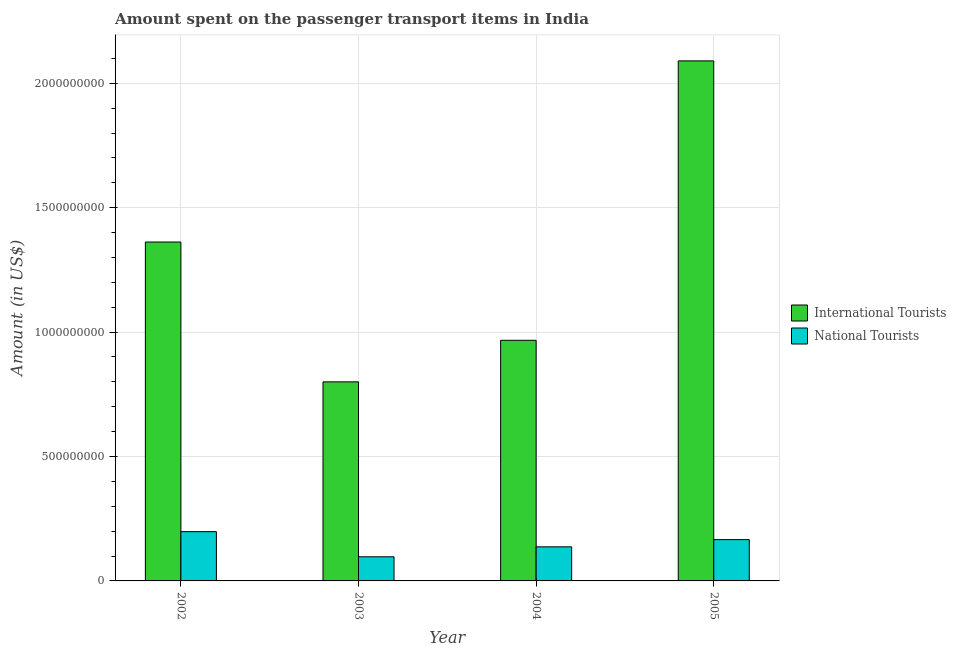How many different coloured bars are there?
Provide a succinct answer. 2. Are the number of bars on each tick of the X-axis equal?
Provide a short and direct response. Yes. How many bars are there on the 2nd tick from the right?
Provide a succinct answer. 2. What is the label of the 1st group of bars from the left?
Provide a succinct answer. 2002. In how many cases, is the number of bars for a given year not equal to the number of legend labels?
Offer a very short reply. 0. What is the amount spent on transport items of national tourists in 2003?
Offer a very short reply. 9.70e+07. Across all years, what is the maximum amount spent on transport items of national tourists?
Offer a very short reply. 1.98e+08. Across all years, what is the minimum amount spent on transport items of international tourists?
Your answer should be compact. 8.00e+08. In which year was the amount spent on transport items of national tourists maximum?
Provide a succinct answer. 2002. In which year was the amount spent on transport items of national tourists minimum?
Give a very brief answer. 2003. What is the total amount spent on transport items of international tourists in the graph?
Give a very brief answer. 5.22e+09. What is the difference between the amount spent on transport items of international tourists in 2003 and that in 2005?
Your answer should be very brief. -1.29e+09. What is the difference between the amount spent on transport items of national tourists in 2005 and the amount spent on transport items of international tourists in 2004?
Offer a very short reply. 2.90e+07. What is the average amount spent on transport items of national tourists per year?
Offer a terse response. 1.50e+08. In how many years, is the amount spent on transport items of national tourists greater than 100000000 US$?
Provide a short and direct response. 3. What is the ratio of the amount spent on transport items of international tourists in 2003 to that in 2004?
Ensure brevity in your answer.  0.83. Is the amount spent on transport items of international tourists in 2004 less than that in 2005?
Provide a succinct answer. Yes. Is the difference between the amount spent on transport items of national tourists in 2003 and 2004 greater than the difference between the amount spent on transport items of international tourists in 2003 and 2004?
Provide a short and direct response. No. What is the difference between the highest and the second highest amount spent on transport items of international tourists?
Offer a very short reply. 7.28e+08. What is the difference between the highest and the lowest amount spent on transport items of international tourists?
Make the answer very short. 1.29e+09. What does the 1st bar from the left in 2004 represents?
Your response must be concise. International Tourists. What does the 1st bar from the right in 2003 represents?
Offer a terse response. National Tourists. Are all the bars in the graph horizontal?
Offer a terse response. No. How many years are there in the graph?
Your answer should be compact. 4. Are the values on the major ticks of Y-axis written in scientific E-notation?
Make the answer very short. No. Does the graph contain grids?
Offer a terse response. Yes. How many legend labels are there?
Give a very brief answer. 2. What is the title of the graph?
Provide a short and direct response. Amount spent on the passenger transport items in India. What is the Amount (in US$) in International Tourists in 2002?
Make the answer very short. 1.36e+09. What is the Amount (in US$) of National Tourists in 2002?
Offer a very short reply. 1.98e+08. What is the Amount (in US$) of International Tourists in 2003?
Keep it short and to the point. 8.00e+08. What is the Amount (in US$) in National Tourists in 2003?
Provide a short and direct response. 9.70e+07. What is the Amount (in US$) of International Tourists in 2004?
Your response must be concise. 9.67e+08. What is the Amount (in US$) in National Tourists in 2004?
Provide a short and direct response. 1.37e+08. What is the Amount (in US$) of International Tourists in 2005?
Provide a short and direct response. 2.09e+09. What is the Amount (in US$) of National Tourists in 2005?
Offer a terse response. 1.66e+08. Across all years, what is the maximum Amount (in US$) in International Tourists?
Your response must be concise. 2.09e+09. Across all years, what is the maximum Amount (in US$) of National Tourists?
Your answer should be compact. 1.98e+08. Across all years, what is the minimum Amount (in US$) of International Tourists?
Your answer should be compact. 8.00e+08. Across all years, what is the minimum Amount (in US$) of National Tourists?
Your response must be concise. 9.70e+07. What is the total Amount (in US$) in International Tourists in the graph?
Give a very brief answer. 5.22e+09. What is the total Amount (in US$) in National Tourists in the graph?
Give a very brief answer. 5.98e+08. What is the difference between the Amount (in US$) of International Tourists in 2002 and that in 2003?
Your response must be concise. 5.62e+08. What is the difference between the Amount (in US$) in National Tourists in 2002 and that in 2003?
Your answer should be compact. 1.01e+08. What is the difference between the Amount (in US$) of International Tourists in 2002 and that in 2004?
Your response must be concise. 3.95e+08. What is the difference between the Amount (in US$) of National Tourists in 2002 and that in 2004?
Offer a very short reply. 6.10e+07. What is the difference between the Amount (in US$) in International Tourists in 2002 and that in 2005?
Provide a short and direct response. -7.28e+08. What is the difference between the Amount (in US$) of National Tourists in 2002 and that in 2005?
Provide a succinct answer. 3.20e+07. What is the difference between the Amount (in US$) of International Tourists in 2003 and that in 2004?
Make the answer very short. -1.67e+08. What is the difference between the Amount (in US$) in National Tourists in 2003 and that in 2004?
Ensure brevity in your answer.  -4.00e+07. What is the difference between the Amount (in US$) of International Tourists in 2003 and that in 2005?
Your answer should be very brief. -1.29e+09. What is the difference between the Amount (in US$) in National Tourists in 2003 and that in 2005?
Provide a short and direct response. -6.90e+07. What is the difference between the Amount (in US$) of International Tourists in 2004 and that in 2005?
Make the answer very short. -1.12e+09. What is the difference between the Amount (in US$) of National Tourists in 2004 and that in 2005?
Ensure brevity in your answer.  -2.90e+07. What is the difference between the Amount (in US$) in International Tourists in 2002 and the Amount (in US$) in National Tourists in 2003?
Offer a terse response. 1.26e+09. What is the difference between the Amount (in US$) in International Tourists in 2002 and the Amount (in US$) in National Tourists in 2004?
Provide a succinct answer. 1.22e+09. What is the difference between the Amount (in US$) of International Tourists in 2002 and the Amount (in US$) of National Tourists in 2005?
Your answer should be compact. 1.20e+09. What is the difference between the Amount (in US$) in International Tourists in 2003 and the Amount (in US$) in National Tourists in 2004?
Offer a terse response. 6.63e+08. What is the difference between the Amount (in US$) of International Tourists in 2003 and the Amount (in US$) of National Tourists in 2005?
Your answer should be very brief. 6.34e+08. What is the difference between the Amount (in US$) of International Tourists in 2004 and the Amount (in US$) of National Tourists in 2005?
Provide a short and direct response. 8.01e+08. What is the average Amount (in US$) in International Tourists per year?
Ensure brevity in your answer.  1.30e+09. What is the average Amount (in US$) of National Tourists per year?
Make the answer very short. 1.50e+08. In the year 2002, what is the difference between the Amount (in US$) of International Tourists and Amount (in US$) of National Tourists?
Offer a terse response. 1.16e+09. In the year 2003, what is the difference between the Amount (in US$) of International Tourists and Amount (in US$) of National Tourists?
Give a very brief answer. 7.03e+08. In the year 2004, what is the difference between the Amount (in US$) of International Tourists and Amount (in US$) of National Tourists?
Make the answer very short. 8.30e+08. In the year 2005, what is the difference between the Amount (in US$) in International Tourists and Amount (in US$) in National Tourists?
Your response must be concise. 1.92e+09. What is the ratio of the Amount (in US$) in International Tourists in 2002 to that in 2003?
Keep it short and to the point. 1.7. What is the ratio of the Amount (in US$) in National Tourists in 2002 to that in 2003?
Make the answer very short. 2.04. What is the ratio of the Amount (in US$) in International Tourists in 2002 to that in 2004?
Make the answer very short. 1.41. What is the ratio of the Amount (in US$) in National Tourists in 2002 to that in 2004?
Your answer should be compact. 1.45. What is the ratio of the Amount (in US$) of International Tourists in 2002 to that in 2005?
Offer a very short reply. 0.65. What is the ratio of the Amount (in US$) of National Tourists in 2002 to that in 2005?
Give a very brief answer. 1.19. What is the ratio of the Amount (in US$) in International Tourists in 2003 to that in 2004?
Provide a short and direct response. 0.83. What is the ratio of the Amount (in US$) of National Tourists in 2003 to that in 2004?
Provide a succinct answer. 0.71. What is the ratio of the Amount (in US$) in International Tourists in 2003 to that in 2005?
Provide a succinct answer. 0.38. What is the ratio of the Amount (in US$) in National Tourists in 2003 to that in 2005?
Offer a very short reply. 0.58. What is the ratio of the Amount (in US$) of International Tourists in 2004 to that in 2005?
Your answer should be compact. 0.46. What is the ratio of the Amount (in US$) of National Tourists in 2004 to that in 2005?
Provide a succinct answer. 0.83. What is the difference between the highest and the second highest Amount (in US$) of International Tourists?
Provide a short and direct response. 7.28e+08. What is the difference between the highest and the second highest Amount (in US$) in National Tourists?
Your answer should be very brief. 3.20e+07. What is the difference between the highest and the lowest Amount (in US$) of International Tourists?
Offer a very short reply. 1.29e+09. What is the difference between the highest and the lowest Amount (in US$) in National Tourists?
Make the answer very short. 1.01e+08. 